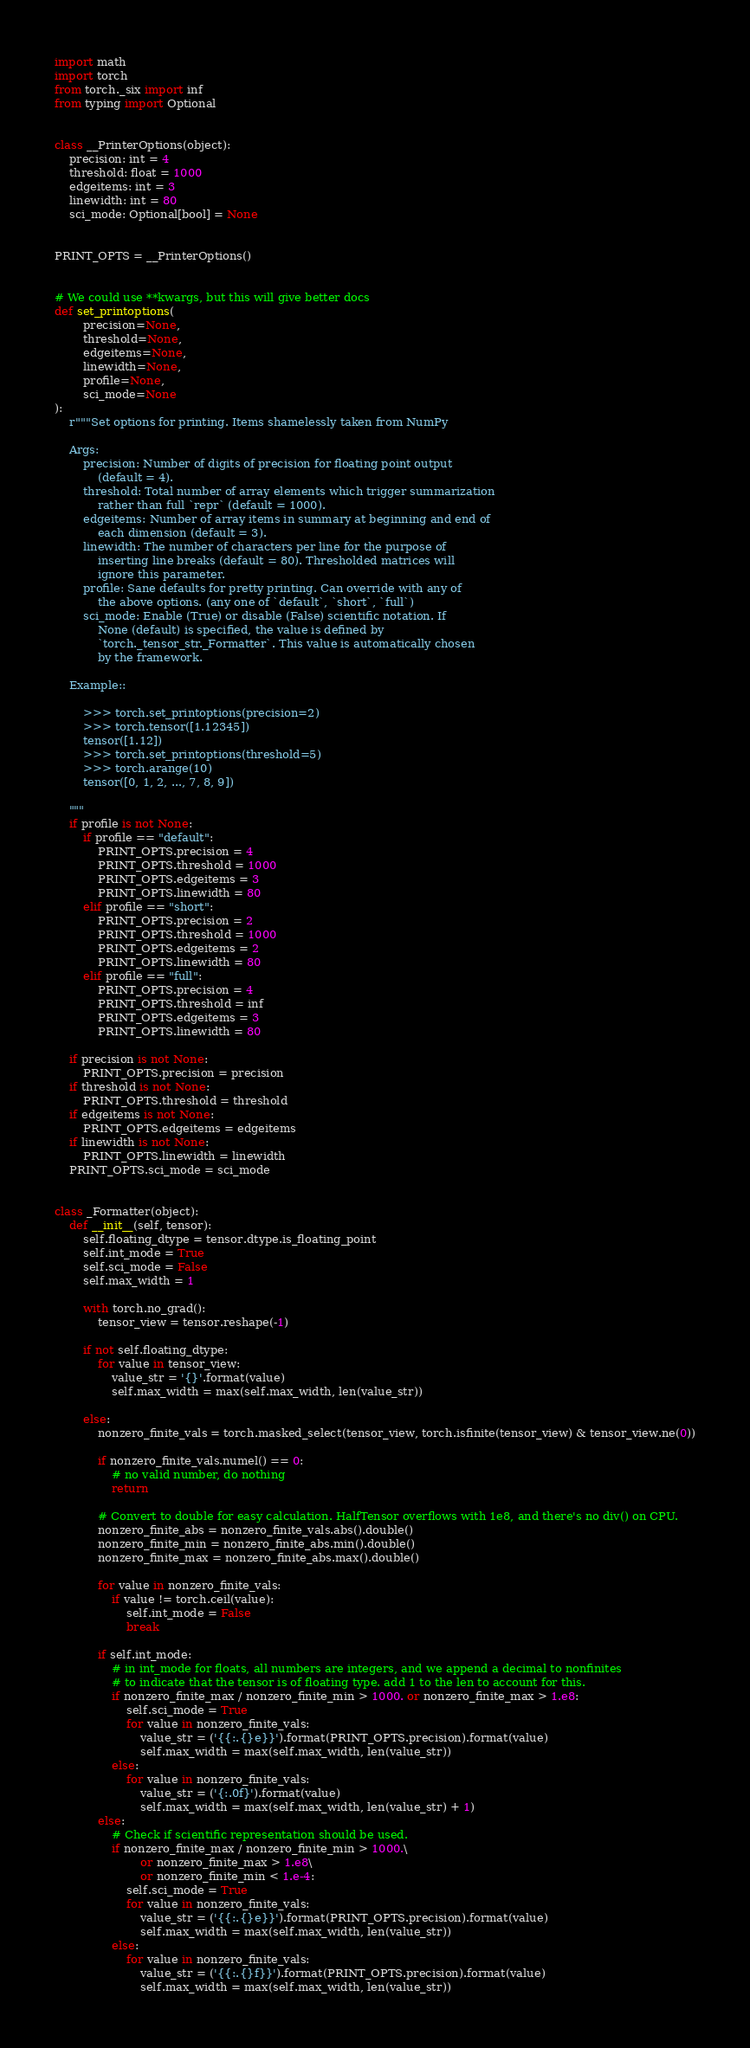<code> <loc_0><loc_0><loc_500><loc_500><_Python_>import math
import torch
from torch._six import inf
from typing import Optional


class __PrinterOptions(object):
    precision: int = 4
    threshold: float = 1000
    edgeitems: int = 3
    linewidth: int = 80
    sci_mode: Optional[bool] = None


PRINT_OPTS = __PrinterOptions()


# We could use **kwargs, but this will give better docs
def set_printoptions(
        precision=None,
        threshold=None,
        edgeitems=None,
        linewidth=None,
        profile=None,
        sci_mode=None
):
    r"""Set options for printing. Items shamelessly taken from NumPy

    Args:
        precision: Number of digits of precision for floating point output
            (default = 4).
        threshold: Total number of array elements which trigger summarization
            rather than full `repr` (default = 1000).
        edgeitems: Number of array items in summary at beginning and end of
            each dimension (default = 3).
        linewidth: The number of characters per line for the purpose of
            inserting line breaks (default = 80). Thresholded matrices will
            ignore this parameter.
        profile: Sane defaults for pretty printing. Can override with any of
            the above options. (any one of `default`, `short`, `full`)
        sci_mode: Enable (True) or disable (False) scientific notation. If
            None (default) is specified, the value is defined by
            `torch._tensor_str._Formatter`. This value is automatically chosen
            by the framework.

    Example::

        >>> torch.set_printoptions(precision=2)
        >>> torch.tensor([1.12345])
        tensor([1.12])
        >>> torch.set_printoptions(threshold=5)
        >>> torch.arange(10)
        tensor([0, 1, 2, ..., 7, 8, 9])

    """
    if profile is not None:
        if profile == "default":
            PRINT_OPTS.precision = 4
            PRINT_OPTS.threshold = 1000
            PRINT_OPTS.edgeitems = 3
            PRINT_OPTS.linewidth = 80
        elif profile == "short":
            PRINT_OPTS.precision = 2
            PRINT_OPTS.threshold = 1000
            PRINT_OPTS.edgeitems = 2
            PRINT_OPTS.linewidth = 80
        elif profile == "full":
            PRINT_OPTS.precision = 4
            PRINT_OPTS.threshold = inf
            PRINT_OPTS.edgeitems = 3
            PRINT_OPTS.linewidth = 80

    if precision is not None:
        PRINT_OPTS.precision = precision
    if threshold is not None:
        PRINT_OPTS.threshold = threshold
    if edgeitems is not None:
        PRINT_OPTS.edgeitems = edgeitems
    if linewidth is not None:
        PRINT_OPTS.linewidth = linewidth
    PRINT_OPTS.sci_mode = sci_mode


class _Formatter(object):
    def __init__(self, tensor):
        self.floating_dtype = tensor.dtype.is_floating_point
        self.int_mode = True
        self.sci_mode = False
        self.max_width = 1

        with torch.no_grad():
            tensor_view = tensor.reshape(-1)

        if not self.floating_dtype:
            for value in tensor_view:
                value_str = '{}'.format(value)
                self.max_width = max(self.max_width, len(value_str))

        else:
            nonzero_finite_vals = torch.masked_select(tensor_view, torch.isfinite(tensor_view) & tensor_view.ne(0))

            if nonzero_finite_vals.numel() == 0:
                # no valid number, do nothing
                return

            # Convert to double for easy calculation. HalfTensor overflows with 1e8, and there's no div() on CPU.
            nonzero_finite_abs = nonzero_finite_vals.abs().double()
            nonzero_finite_min = nonzero_finite_abs.min().double()
            nonzero_finite_max = nonzero_finite_abs.max().double()

            for value in nonzero_finite_vals:
                if value != torch.ceil(value):
                    self.int_mode = False
                    break

            if self.int_mode:
                # in int_mode for floats, all numbers are integers, and we append a decimal to nonfinites
                # to indicate that the tensor is of floating type. add 1 to the len to account for this.
                if nonzero_finite_max / nonzero_finite_min > 1000. or nonzero_finite_max > 1.e8:
                    self.sci_mode = True
                    for value in nonzero_finite_vals:
                        value_str = ('{{:.{}e}}').format(PRINT_OPTS.precision).format(value)
                        self.max_width = max(self.max_width, len(value_str))
                else:
                    for value in nonzero_finite_vals:
                        value_str = ('{:.0f}').format(value)
                        self.max_width = max(self.max_width, len(value_str) + 1)
            else:
                # Check if scientific representation should be used.
                if nonzero_finite_max / nonzero_finite_min > 1000.\
                        or nonzero_finite_max > 1.e8\
                        or nonzero_finite_min < 1.e-4:
                    self.sci_mode = True
                    for value in nonzero_finite_vals:
                        value_str = ('{{:.{}e}}').format(PRINT_OPTS.precision).format(value)
                        self.max_width = max(self.max_width, len(value_str))
                else:
                    for value in nonzero_finite_vals:
                        value_str = ('{{:.{}f}}').format(PRINT_OPTS.precision).format(value)
                        self.max_width = max(self.max_width, len(value_str))
</code> 